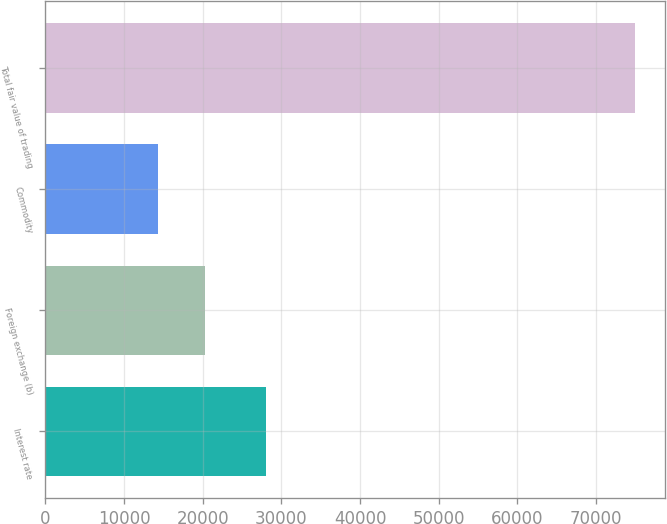Convert chart. <chart><loc_0><loc_0><loc_500><loc_500><bar_chart><fcel>Interest rate<fcel>Foreign exchange (b)<fcel>Commodity<fcel>Total fair value of trading<nl><fcel>28010<fcel>20338<fcel>14267<fcel>74977<nl></chart> 